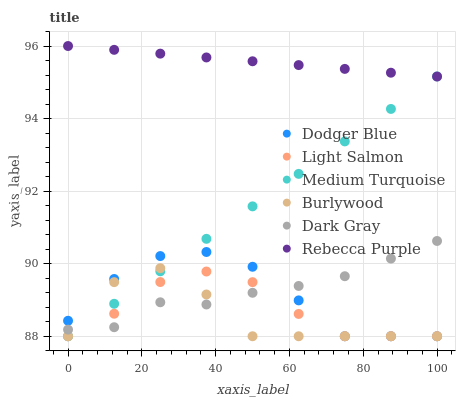Does Burlywood have the minimum area under the curve?
Answer yes or no. Yes. Does Rebecca Purple have the maximum area under the curve?
Answer yes or no. Yes. Does Dark Gray have the minimum area under the curve?
Answer yes or no. No. Does Dark Gray have the maximum area under the curve?
Answer yes or no. No. Is Rebecca Purple the smoothest?
Answer yes or no. Yes. Is Burlywood the roughest?
Answer yes or no. Yes. Is Dark Gray the smoothest?
Answer yes or no. No. Is Dark Gray the roughest?
Answer yes or no. No. Does Light Salmon have the lowest value?
Answer yes or no. Yes. Does Dark Gray have the lowest value?
Answer yes or no. No. Does Rebecca Purple have the highest value?
Answer yes or no. Yes. Does Burlywood have the highest value?
Answer yes or no. No. Is Burlywood less than Rebecca Purple?
Answer yes or no. Yes. Is Rebecca Purple greater than Light Salmon?
Answer yes or no. Yes. Does Burlywood intersect Dark Gray?
Answer yes or no. Yes. Is Burlywood less than Dark Gray?
Answer yes or no. No. Is Burlywood greater than Dark Gray?
Answer yes or no. No. Does Burlywood intersect Rebecca Purple?
Answer yes or no. No. 